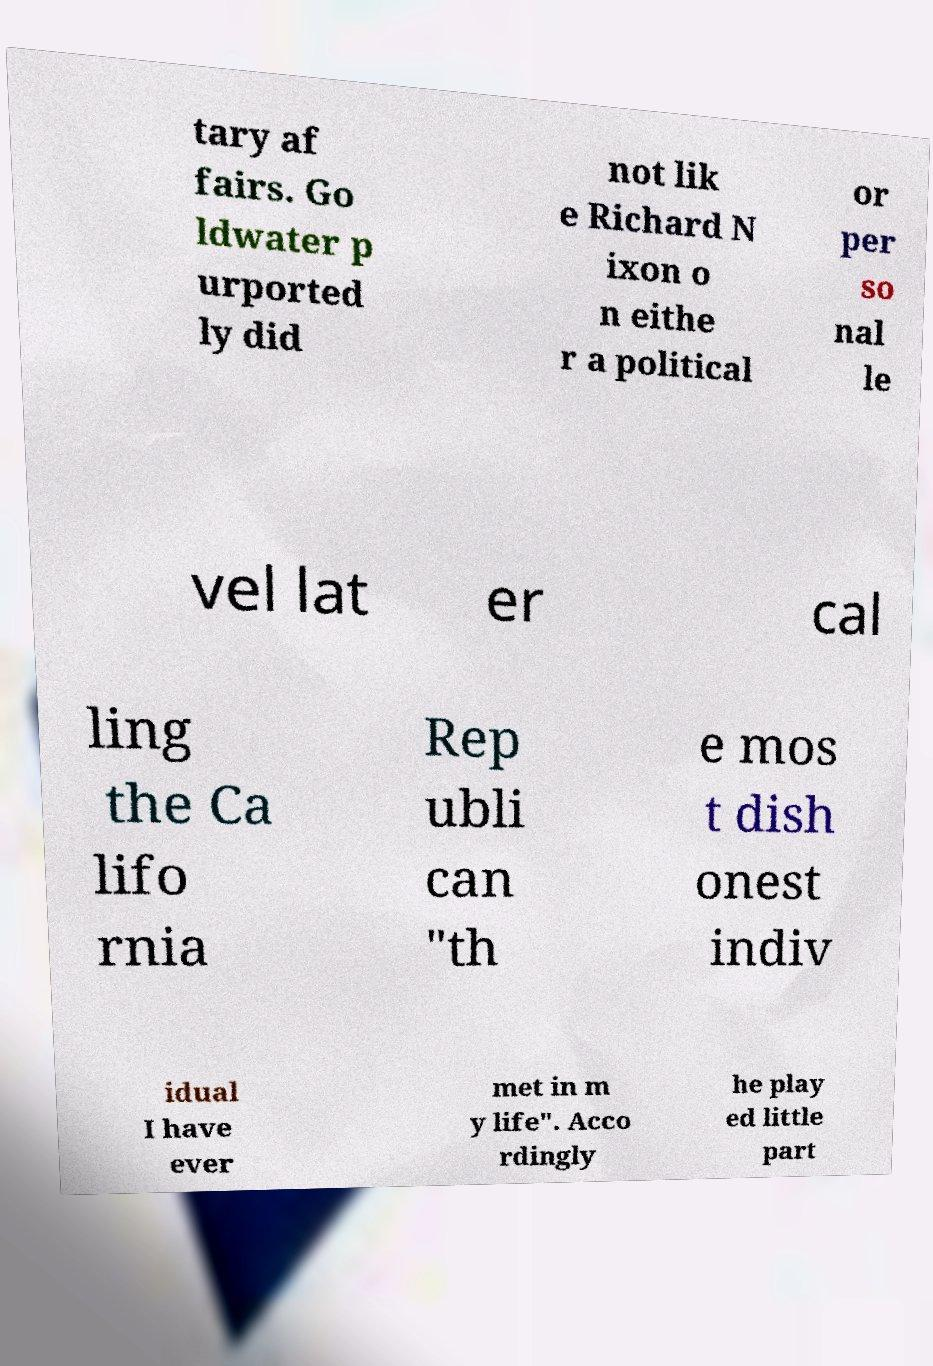Can you accurately transcribe the text from the provided image for me? tary af fairs. Go ldwater p urported ly did not lik e Richard N ixon o n eithe r a political or per so nal le vel lat er cal ling the Ca lifo rnia Rep ubli can "th e mos t dish onest indiv idual I have ever met in m y life". Acco rdingly he play ed little part 